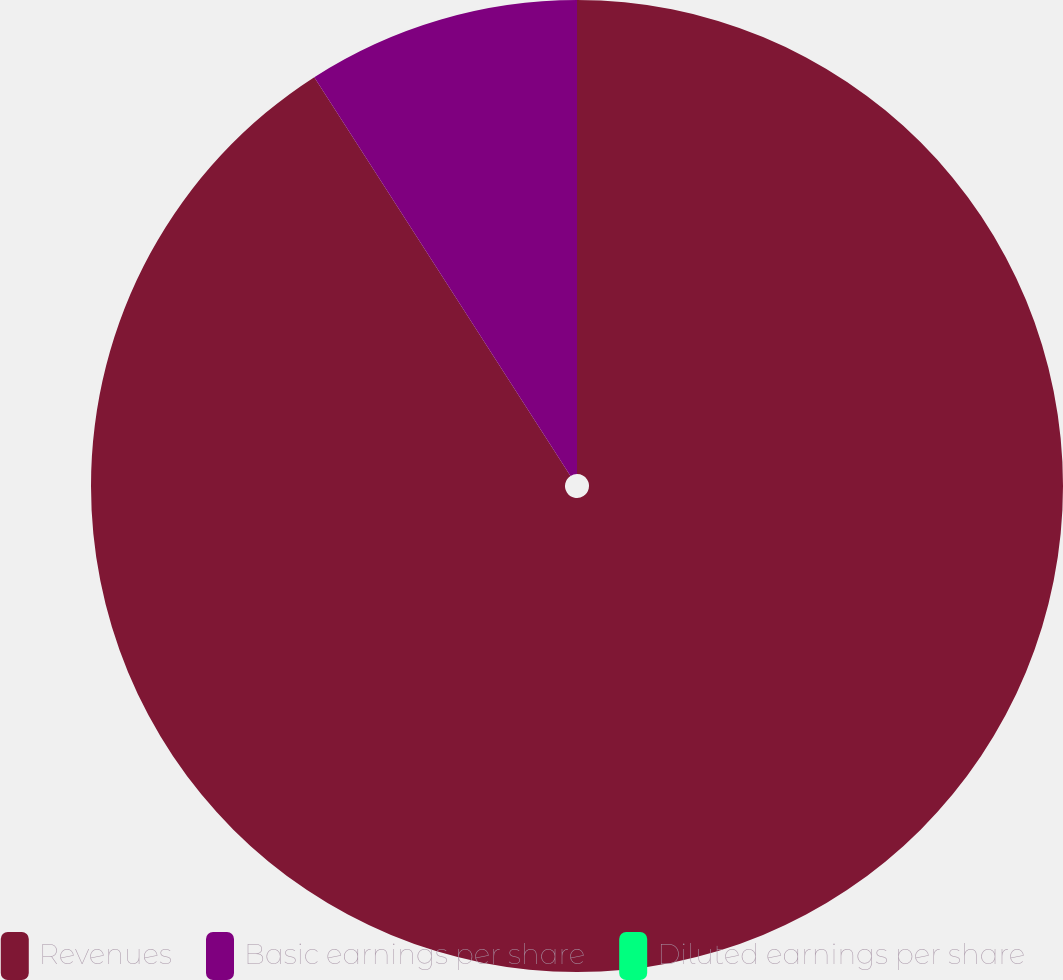Convert chart. <chart><loc_0><loc_0><loc_500><loc_500><pie_chart><fcel>Revenues<fcel>Basic earnings per share<fcel>Diluted earnings per share<nl><fcel>90.91%<fcel>9.09%<fcel>0.0%<nl></chart> 